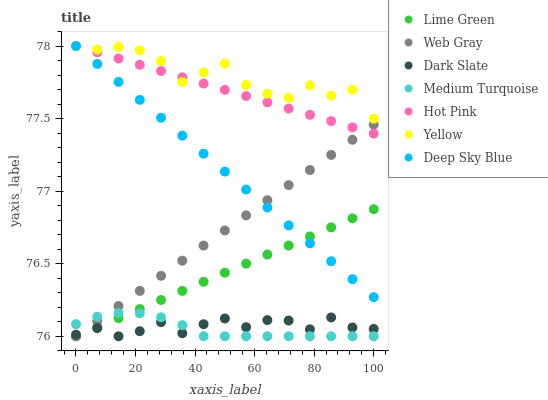Does Medium Turquoise have the minimum area under the curve?
Answer yes or no. Yes. Does Yellow have the maximum area under the curve?
Answer yes or no. Yes. Does Deep Sky Blue have the minimum area under the curve?
Answer yes or no. No. Does Deep Sky Blue have the maximum area under the curve?
Answer yes or no. No. Is Lime Green the smoothest?
Answer yes or no. Yes. Is Yellow the roughest?
Answer yes or no. Yes. Is Deep Sky Blue the smoothest?
Answer yes or no. No. Is Deep Sky Blue the roughest?
Answer yes or no. No. Does Web Gray have the lowest value?
Answer yes or no. Yes. Does Deep Sky Blue have the lowest value?
Answer yes or no. No. Does Yellow have the highest value?
Answer yes or no. Yes. Does Dark Slate have the highest value?
Answer yes or no. No. Is Dark Slate less than Yellow?
Answer yes or no. Yes. Is Yellow greater than Medium Turquoise?
Answer yes or no. Yes. Does Dark Slate intersect Web Gray?
Answer yes or no. Yes. Is Dark Slate less than Web Gray?
Answer yes or no. No. Is Dark Slate greater than Web Gray?
Answer yes or no. No. Does Dark Slate intersect Yellow?
Answer yes or no. No. 